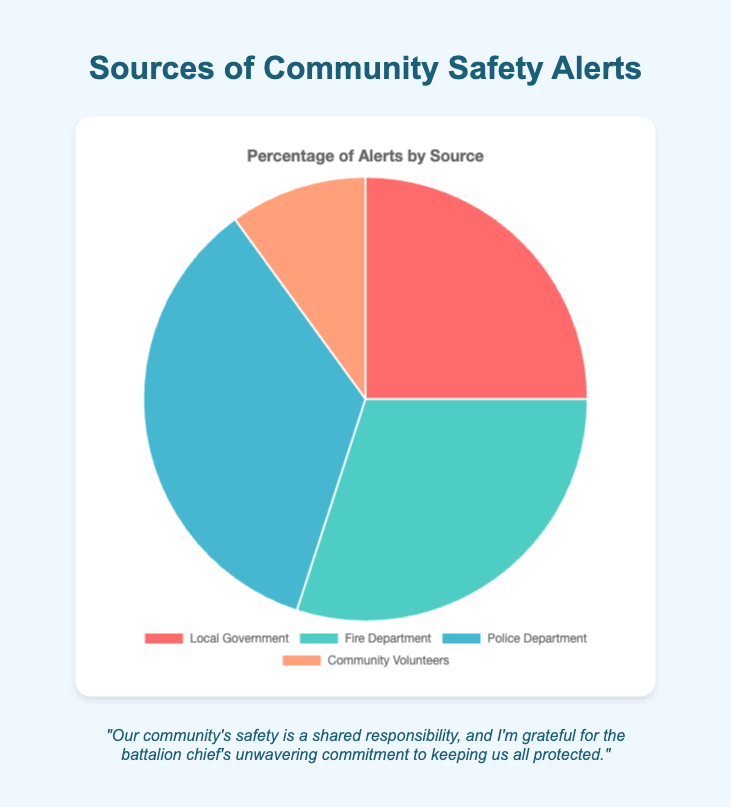Which source contributes the most to community safety alerts? By examining the pie chart, we identify which segment is the largest. The largest segment corresponds to the Police Department.
Answer: Police Department What is the sum of the alert percentages contributed by the Local Government and Community Volunteers? Add the alert percentages of Local Government (25%) and Community Volunteers (10%). 25% + 10% equals 35%.
Answer: 35% How much more does the Fire Department contribute to alerts compared to Community Volunteers? Subtract the Community Volunteers' percentage (10%) from the Fire Department's percentage (30%). 30% - 10% equals 20%.
Answer: 20% What is the difference between the alert percentages of the Police Department and Fire Department? Subtract the Fire Department's percentage (30%) from the Police Department's percentage (35%). 35% - 30% equals 5%.
Answer: 5% Which source contributes the least to community safety alerts? By examining the pie chart, we identify which segment is the smallest. The smallest segment corresponds to Community Volunteers.
Answer: Community Volunteers What is the combined percentage of alerts from the Fire Department and the Police Department? Add the alert percentages of the Fire Department (30%) and Police Department (35%). 30% + 35% equals 65%.
Answer: 65% What percentage more does the Police Department contribute to alerts than the Local Government? Subtract the Local Government's percentage (25%) from the Police Department's percentage (35%). 35% - 25% equals 10%.
Answer: 10% What colors are used to represent the sources of community safety alerts? Identify the colors used in the pie chart segments corresponding to each source. Local Government is red, Fire Department is green, Police Department is blue, and Community Volunteers is orange.
Answer: Red, Green, Blue, Orange Are the contributions of the Local Government and Fire Department combined more or less than the contribution of the Police Department? Add the percentages of Local Government (25%) and Fire Department (30%), which equals 55%. Compare to Police Department's 35%. 55% is more than 35%.
Answer: More 